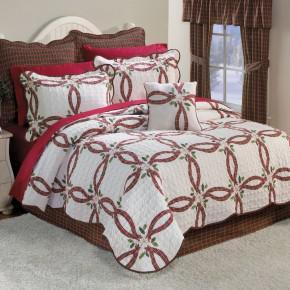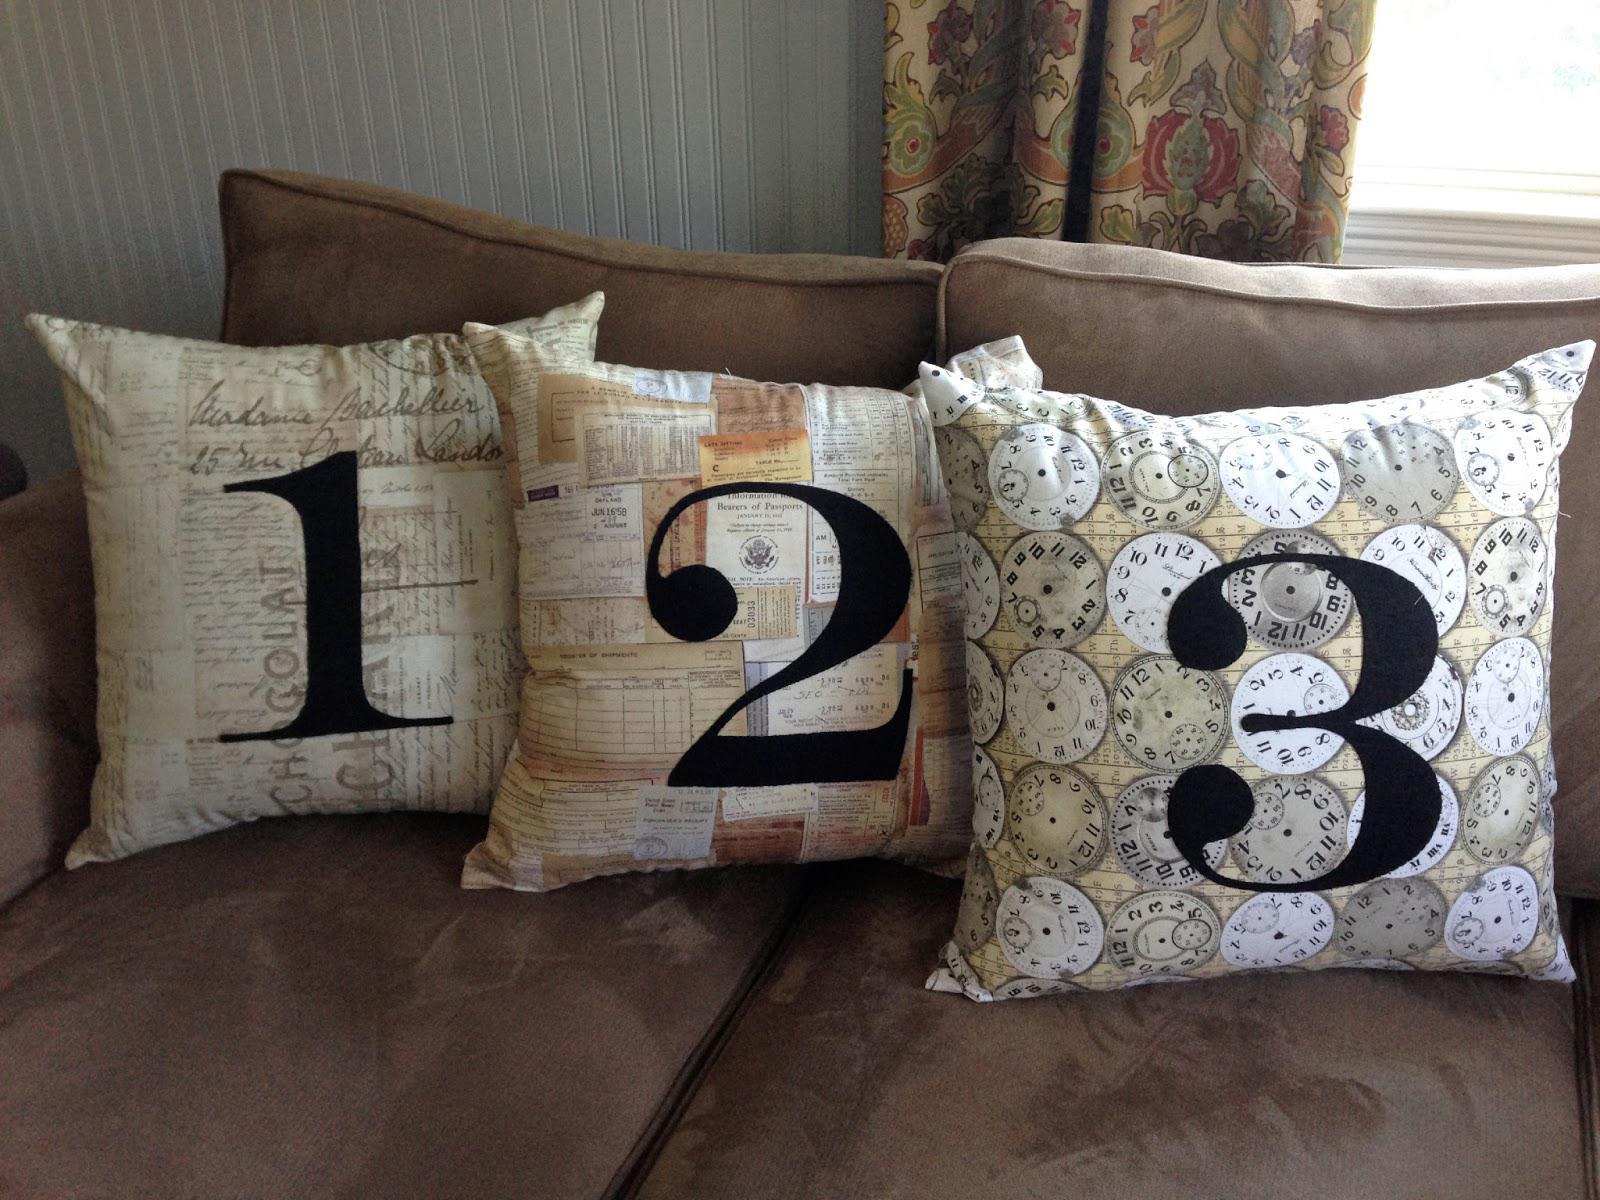The first image is the image on the left, the second image is the image on the right. For the images displayed, is the sentence "Three throw cushions sit on the sofa in the image on the right." factually correct? Answer yes or no. Yes. The first image is the image on the left, the second image is the image on the right. Evaluate the accuracy of this statement regarding the images: "The right image features multiple fringed pillows with a textured look and colors that include burgundy and brown.". Is it true? Answer yes or no. No. 